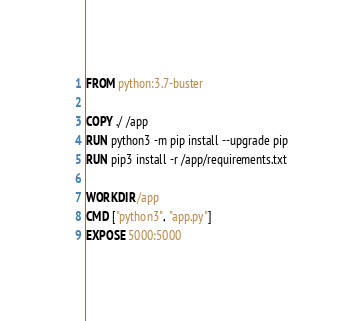Convert code to text. <code><loc_0><loc_0><loc_500><loc_500><_Dockerfile_>FROM python:3.7-buster

COPY ./ /app
RUN python3 -m pip install --upgrade pip
RUN pip3 install -r /app/requirements.txt

WORKDIR /app
CMD ["python3", "app.py"]
EXPOSE 5000:5000
</code> 